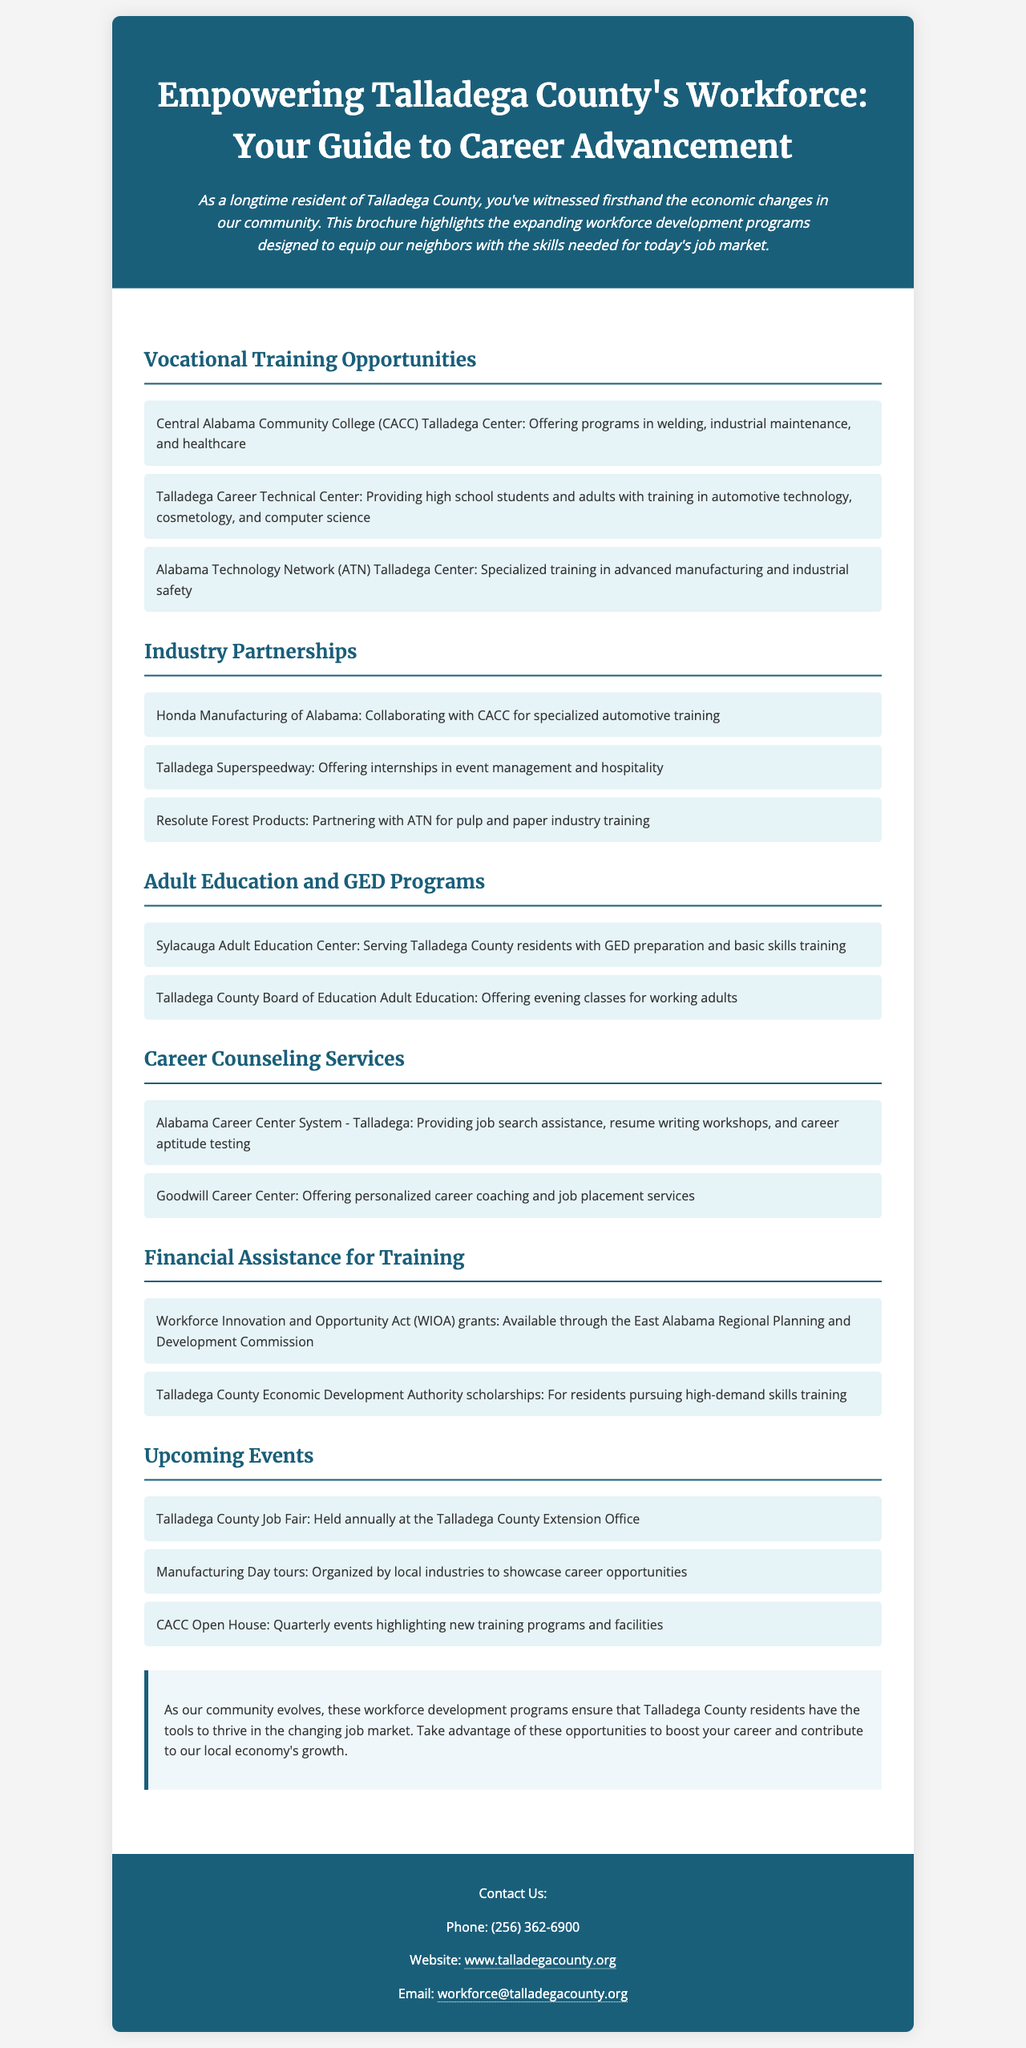What is the title of the brochure? The title is explicitly stated at the top of the document.
Answer: Empowering Talladega County's Workforce: Your Guide to Career Advancement Which institution offers programs in welding and industrial maintenance? The document mentions specific vocational training opportunities provided by local institutions.
Answer: Central Alabama Community College (CACC) Talladega Center What type of training does the Talladega Career Technical Center provide? The document lists different training opportunities by this center, focusing on automotive technology and more.
Answer: Automotive technology, cosmetology, and computer science Which manufacturing company collaborates with CACC? The document lists partnerships between workforce programs and local industries, including specific collaborations.
Answer: Honda Manufacturing of Alabama What kind of financial assistance is available for training? The section on financial assistance details the types of grants and scholarships provided for training programs.
Answer: WIOA grants and scholarships How often is the Talladega County Job Fair held? The document mentions the frequency of scheduled events, including job fairs.
Answer: Annually What type of support does the Alabama Career Center System - Talladega provide? The brochure highlights various services offered, specifically in job search and career coaching.
Answer: Job search assistance and resume writing workshops What is the contact phone number for more information? The document provides specific contact details including a phone number for inquiries.
Answer: (256) 362-6900 What does the conclusion emphasize regarding community evolution? The conclusion summarizes the main purpose of the workforce programs in the context of local economic growth.
Answer: Tools to thrive in the changing job market 